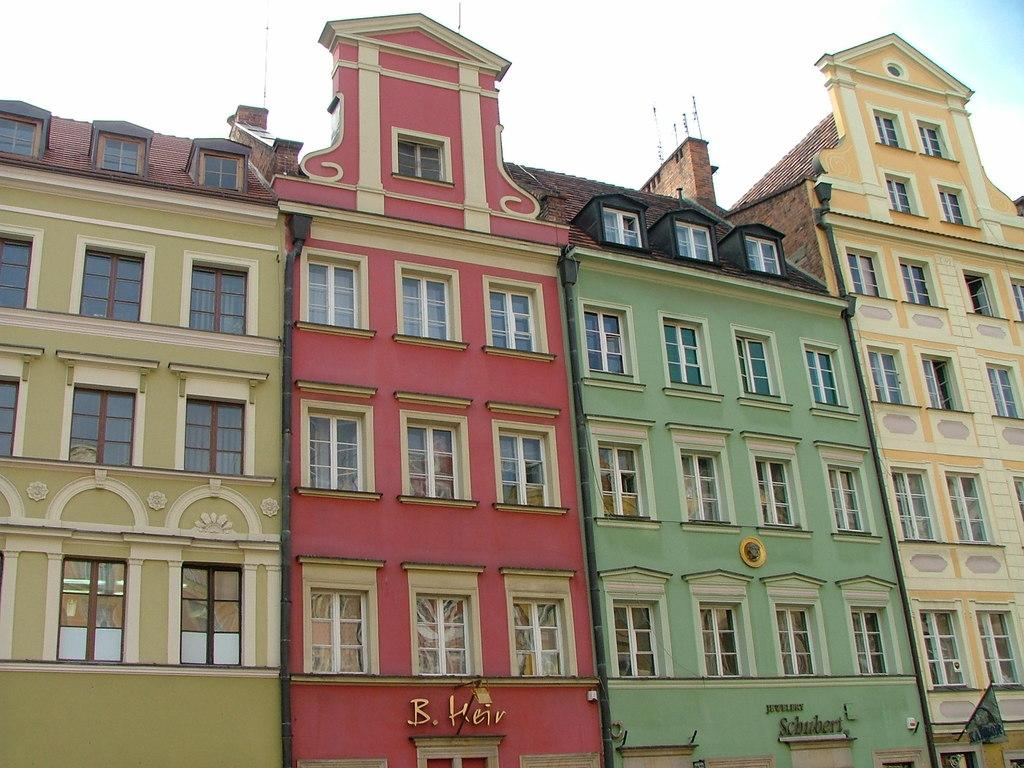What type of structures are visible in the image? There are buildings with windows in the image. What features can be seen on the buildings? The buildings have pipes. What is located at the bottom of the image? There are name boards and a flag at the bottom of the image. What is visible at the top of the image? The sky is visible at the top of the image. What type of creature is responsible for collecting taxes in the image? There is no creature or mention of taxes in the image. 